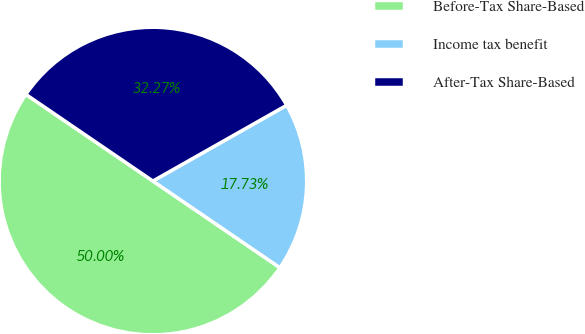Convert chart. <chart><loc_0><loc_0><loc_500><loc_500><pie_chart><fcel>Before-Tax Share-Based<fcel>Income tax benefit<fcel>After-Tax Share-Based<nl><fcel>50.0%<fcel>17.73%<fcel>32.27%<nl></chart> 